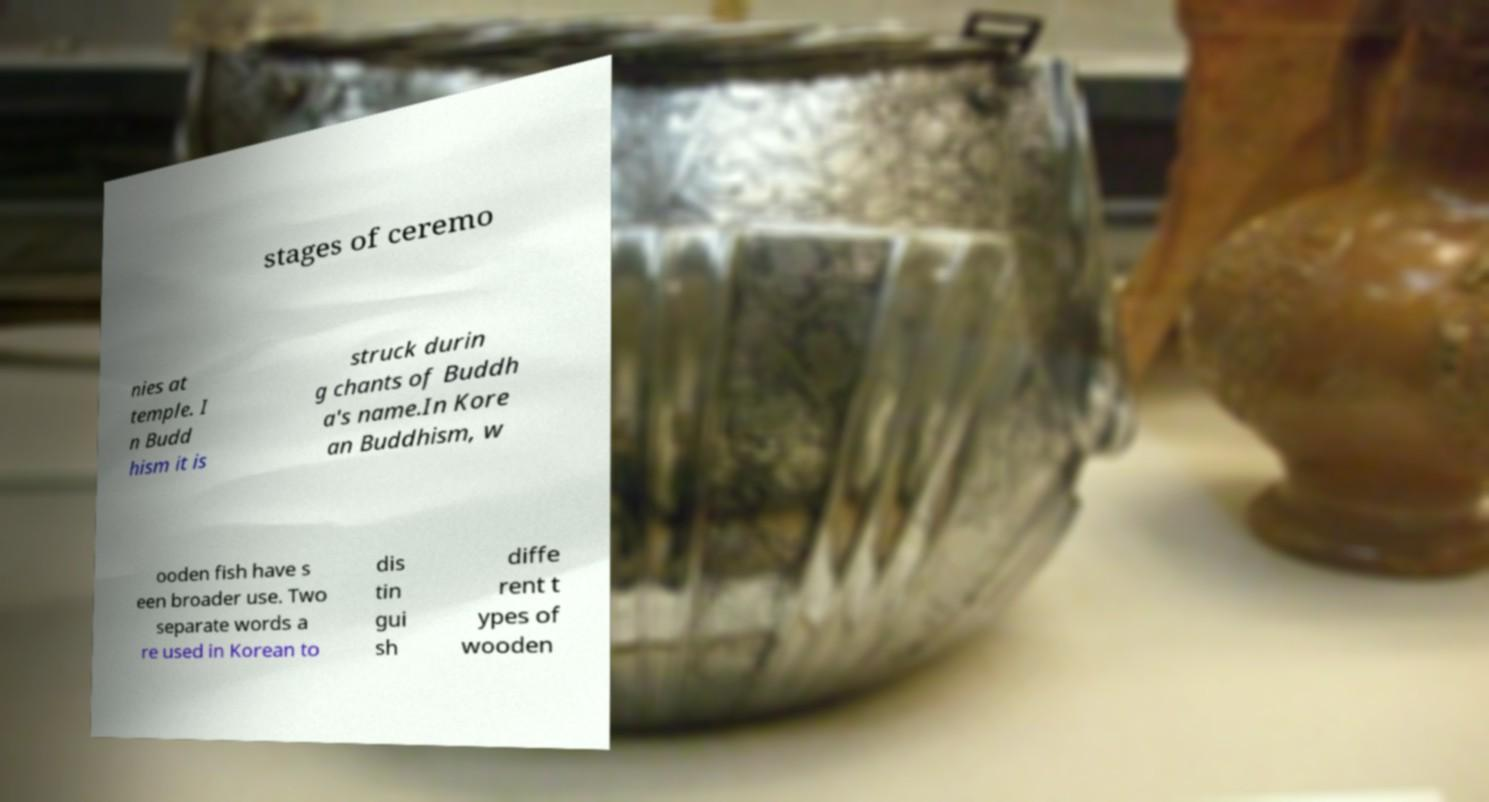Please identify and transcribe the text found in this image. stages of ceremo nies at temple. I n Budd hism it is struck durin g chants of Buddh a's name.In Kore an Buddhism, w ooden fish have s een broader use. Two separate words a re used in Korean to dis tin gui sh diffe rent t ypes of wooden 